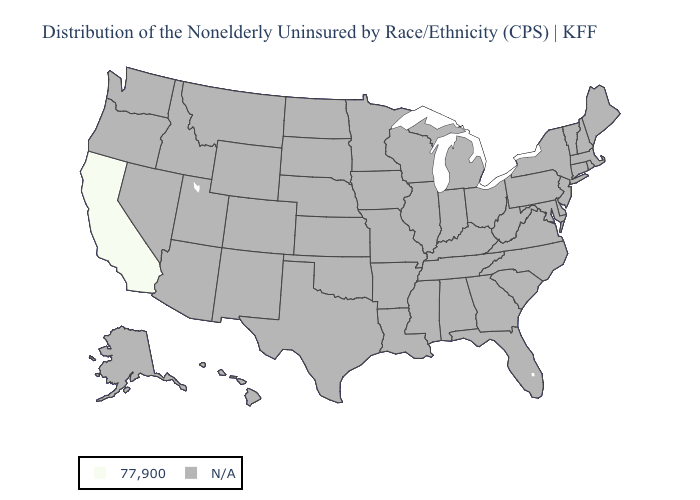What is the highest value in the USA?
Write a very short answer. 77,900. Name the states that have a value in the range N/A?
Give a very brief answer. Alabama, Alaska, Arizona, Arkansas, Colorado, Connecticut, Delaware, Florida, Georgia, Hawaii, Idaho, Illinois, Indiana, Iowa, Kansas, Kentucky, Louisiana, Maine, Maryland, Massachusetts, Michigan, Minnesota, Mississippi, Missouri, Montana, Nebraska, Nevada, New Hampshire, New Jersey, New Mexico, New York, North Carolina, North Dakota, Ohio, Oklahoma, Oregon, Pennsylvania, Rhode Island, South Carolina, South Dakota, Tennessee, Texas, Utah, Vermont, Virginia, Washington, West Virginia, Wisconsin, Wyoming. Does the first symbol in the legend represent the smallest category?
Be succinct. No. Name the states that have a value in the range 77,900?
Concise answer only. California. Name the states that have a value in the range 77,900?
Be succinct. California. How many symbols are there in the legend?
Be succinct. 2. Name the states that have a value in the range 77,900?
Concise answer only. California. Name the states that have a value in the range N/A?
Keep it brief. Alabama, Alaska, Arizona, Arkansas, Colorado, Connecticut, Delaware, Florida, Georgia, Hawaii, Idaho, Illinois, Indiana, Iowa, Kansas, Kentucky, Louisiana, Maine, Maryland, Massachusetts, Michigan, Minnesota, Mississippi, Missouri, Montana, Nebraska, Nevada, New Hampshire, New Jersey, New Mexico, New York, North Carolina, North Dakota, Ohio, Oklahoma, Oregon, Pennsylvania, Rhode Island, South Carolina, South Dakota, Tennessee, Texas, Utah, Vermont, Virginia, Washington, West Virginia, Wisconsin, Wyoming. What is the value of Missouri?
Give a very brief answer. N/A. 